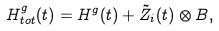<formula> <loc_0><loc_0><loc_500><loc_500>H _ { t o t } ^ { g } ( t ) = H ^ { g } ( t ) + \tilde { Z } _ { i } ( t ) \otimes B ,</formula> 